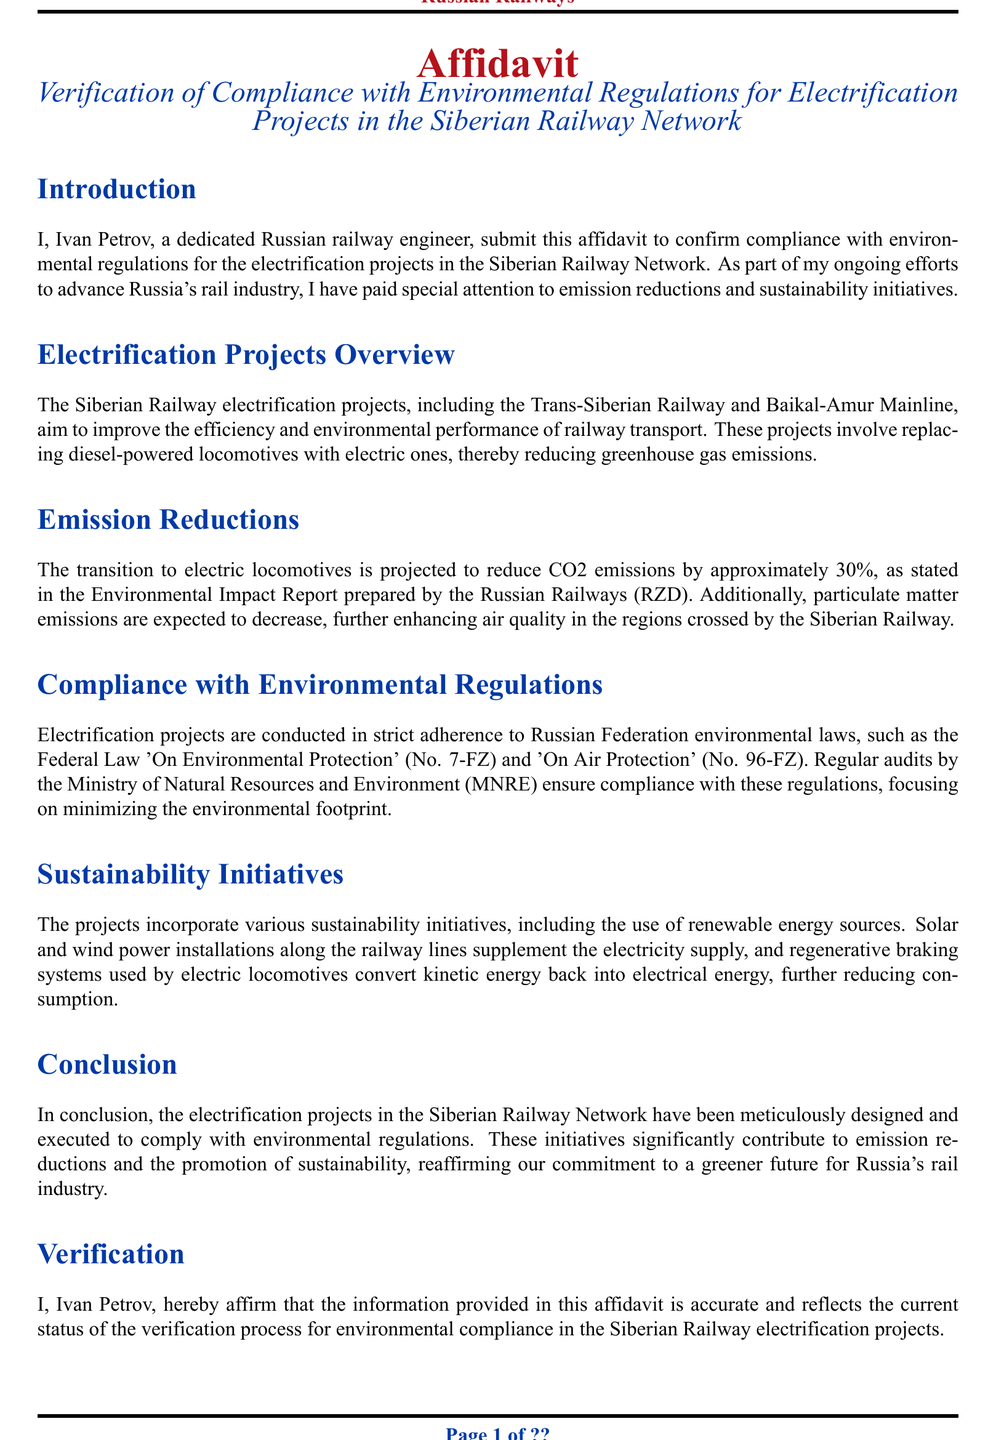What is the name of the affiant? The affiant's name is mentioned at the beginning of the document as Ivan Petrov.
Answer: Ivan Petrov What is the main aim of the electrification projects? The main aim of the electrification projects is to improve the efficiency and environmental performance of railway transport.
Answer: improve efficiency and environmental performance By how much are CO2 emissions projected to be reduced? The document specifies that the CO2 emissions are projected to be reduced by approximately 30%.
Answer: 30% Which environmental laws do the projects comply with? The document identifies two key laws: the Federal Law 'On Environmental Protection' and 'On Air Protection'.
Answer: 'On Environmental Protection' and 'On Air Protection' What sustainability initiative is mentioned regarding energy sources? The projects incorporate the use of renewable energy sources, including solar and wind power installations.
Answer: renewable energy sources How much does particulate matter emissions expect to decrease? The document indicates that particulate matter emissions are expected to decrease, but it does not specify a quantitative measure.
Answer: decrease (no specific number) Who conducts regular audits for compliance? The regular audits to ensure compliance are conducted by the Ministry of Natural Resources and Environment.
Answer: Ministry of Natural Resources and Environment What technology is mentioned to reduce electricity consumption in locomotives? The document states that regenerative braking systems are used by electric locomotives to convert kinetic energy back into electrical energy.
Answer: regenerative braking systems 